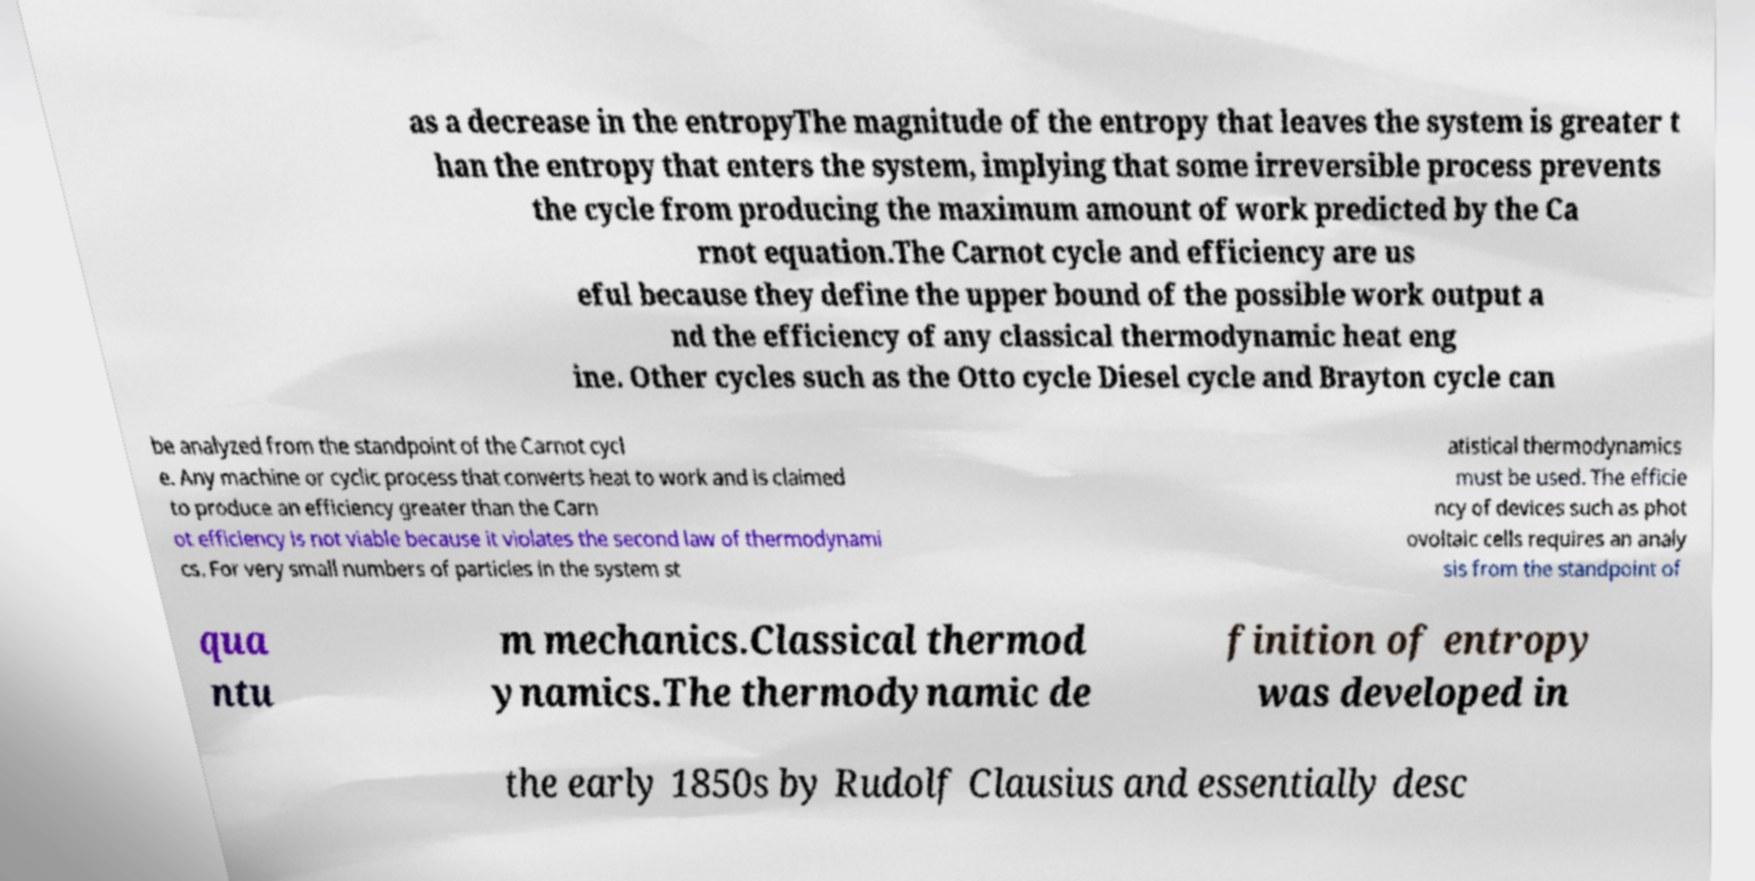Can you accurately transcribe the text from the provided image for me? as a decrease in the entropyThe magnitude of the entropy that leaves the system is greater t han the entropy that enters the system, implying that some irreversible process prevents the cycle from producing the maximum amount of work predicted by the Ca rnot equation.The Carnot cycle and efficiency are us eful because they define the upper bound of the possible work output a nd the efficiency of any classical thermodynamic heat eng ine. Other cycles such as the Otto cycle Diesel cycle and Brayton cycle can be analyzed from the standpoint of the Carnot cycl e. Any machine or cyclic process that converts heat to work and is claimed to produce an efficiency greater than the Carn ot efficiency is not viable because it violates the second law of thermodynami cs. For very small numbers of particles in the system st atistical thermodynamics must be used. The efficie ncy of devices such as phot ovoltaic cells requires an analy sis from the standpoint of qua ntu m mechanics.Classical thermod ynamics.The thermodynamic de finition of entropy was developed in the early 1850s by Rudolf Clausius and essentially desc 